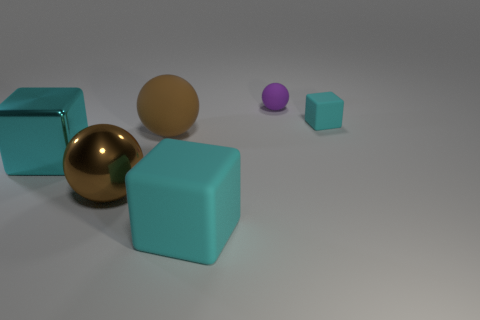Subtract 1 spheres. How many spheres are left? 2 Add 1 large yellow rubber cylinders. How many objects exist? 7 Add 2 big purple rubber cubes. How many big purple rubber cubes exist? 2 Subtract 0 purple cylinders. How many objects are left? 6 Subtract all rubber things. Subtract all purple metal cubes. How many objects are left? 2 Add 4 purple rubber spheres. How many purple rubber spheres are left? 5 